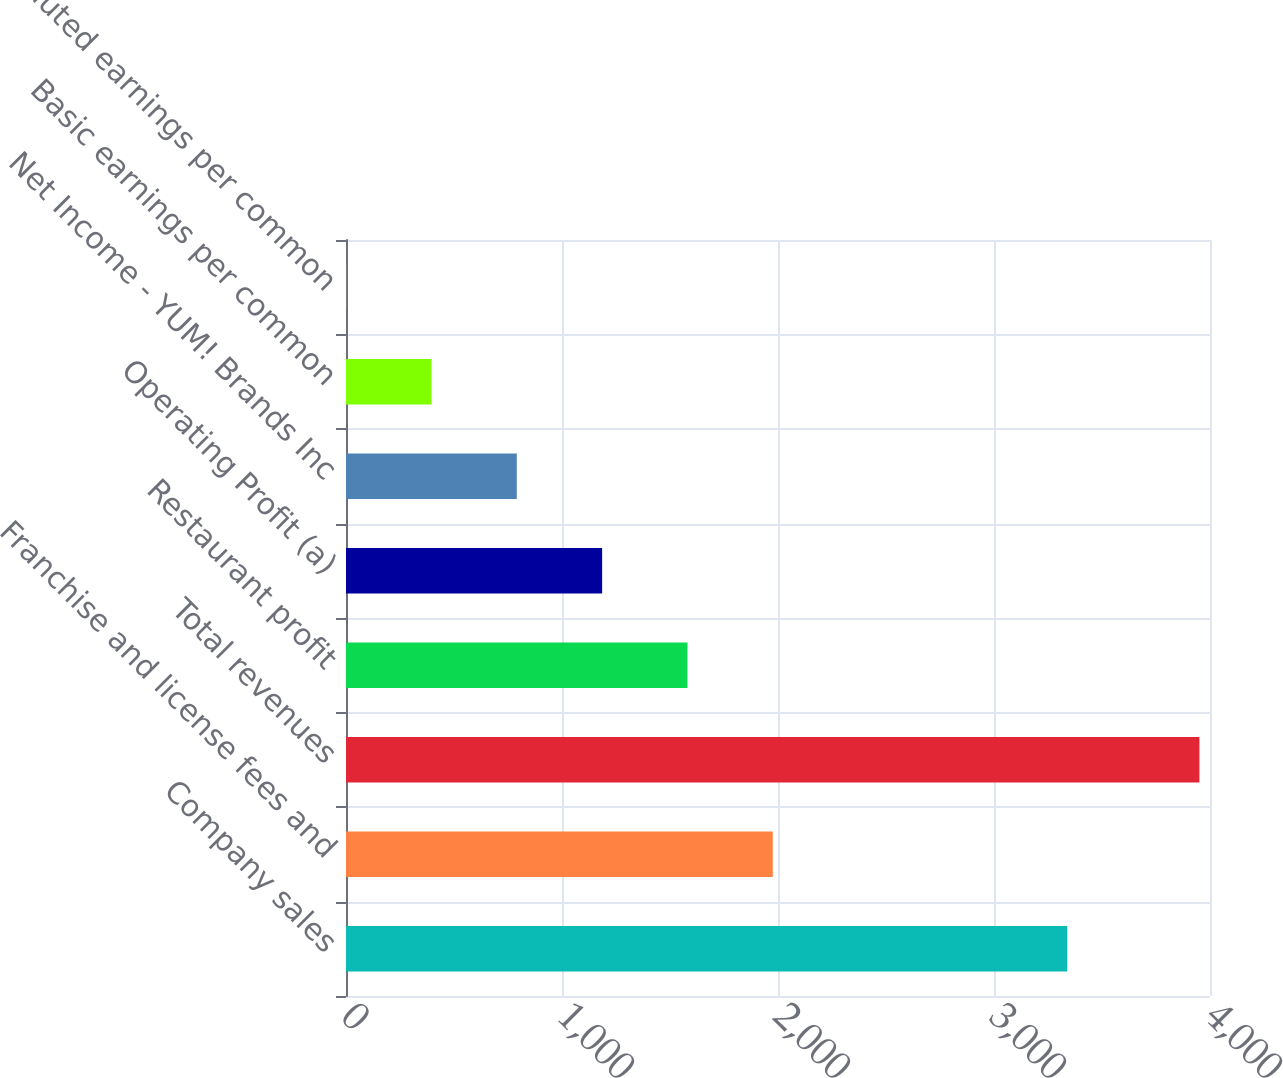<chart> <loc_0><loc_0><loc_500><loc_500><bar_chart><fcel>Company sales<fcel>Franchise and license fees and<fcel>Total revenues<fcel>Restaurant profit<fcel>Operating Profit (a)<fcel>Net Income - YUM! Brands Inc<fcel>Basic earnings per common<fcel>Diluted earnings per common<nl><fcel>3339<fcel>1975.83<fcel>3951<fcel>1580.79<fcel>1185.75<fcel>790.71<fcel>395.67<fcel>0.63<nl></chart> 